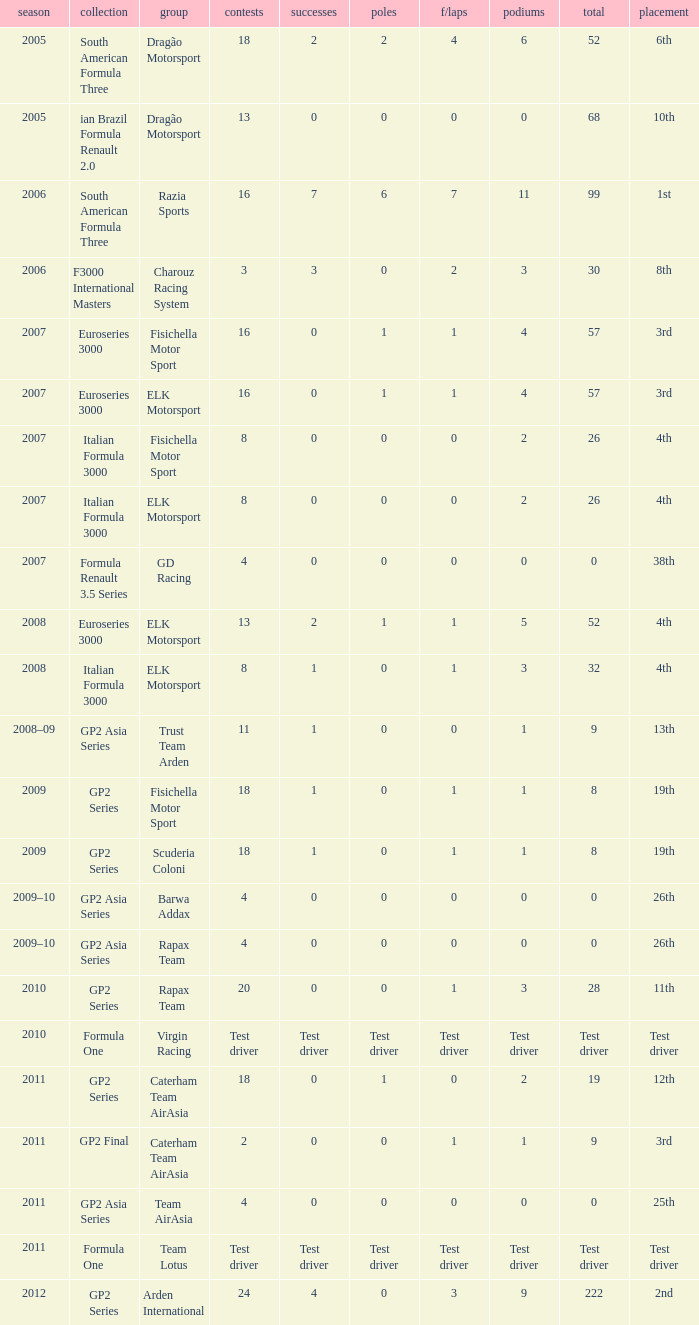In which season did he have 0 Poles and 19th position in the GP2 Series? 2009, 2009. 